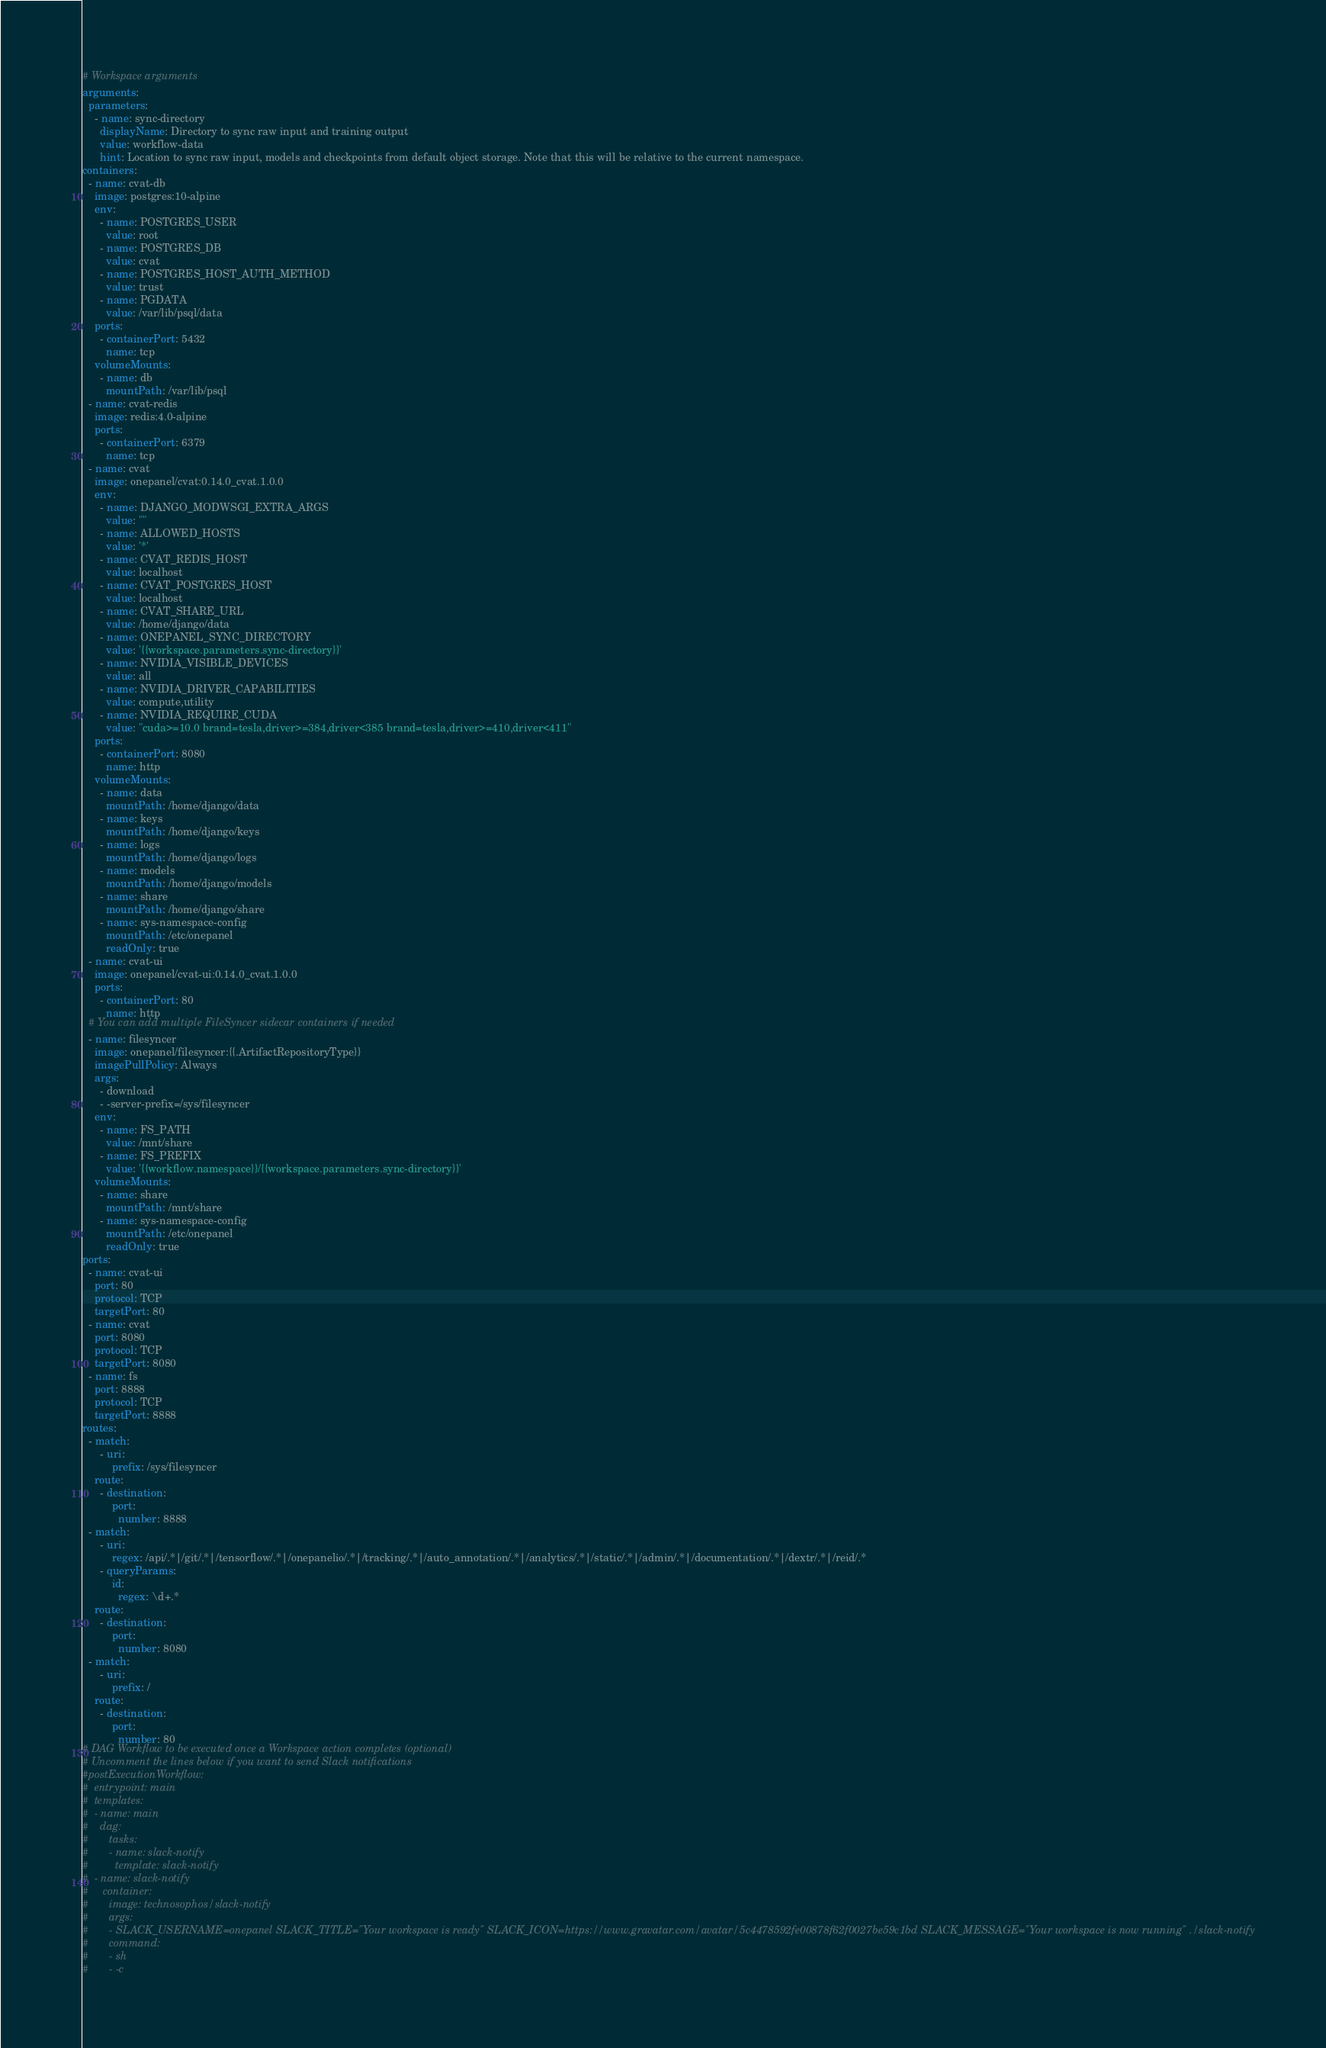<code> <loc_0><loc_0><loc_500><loc_500><_YAML_># Workspace arguments
arguments:
  parameters:
    - name: sync-directory
      displayName: Directory to sync raw input and training output
      value: workflow-data
      hint: Location to sync raw input, models and checkpoints from default object storage. Note that this will be relative to the current namespace.
containers:
  - name: cvat-db
    image: postgres:10-alpine
    env:
      - name: POSTGRES_USER
        value: root
      - name: POSTGRES_DB
        value: cvat
      - name: POSTGRES_HOST_AUTH_METHOD
        value: trust
      - name: PGDATA
        value: /var/lib/psql/data
    ports:
      - containerPort: 5432
        name: tcp
    volumeMounts:
      - name: db
        mountPath: /var/lib/psql
  - name: cvat-redis
    image: redis:4.0-alpine
    ports:
      - containerPort: 6379
        name: tcp
  - name: cvat
    image: onepanel/cvat:0.14.0_cvat.1.0.0
    env:
      - name: DJANGO_MODWSGI_EXTRA_ARGS
        value: ""
      - name: ALLOWED_HOSTS
        value: '*'
      - name: CVAT_REDIS_HOST
        value: localhost
      - name: CVAT_POSTGRES_HOST
        value: localhost
      - name: CVAT_SHARE_URL
        value: /home/django/data
      - name: ONEPANEL_SYNC_DIRECTORY
        value: '{{workspace.parameters.sync-directory}}'
      - name: NVIDIA_VISIBLE_DEVICES
        value: all
      - name: NVIDIA_DRIVER_CAPABILITIES
        value: compute,utility
      - name: NVIDIA_REQUIRE_CUDA
        value: "cuda>=10.0 brand=tesla,driver>=384,driver<385 brand=tesla,driver>=410,driver<411"
    ports:
      - containerPort: 8080
        name: http
    volumeMounts:
      - name: data
        mountPath: /home/django/data
      - name: keys
        mountPath: /home/django/keys
      - name: logs
        mountPath: /home/django/logs
      - name: models
        mountPath: /home/django/models
      - name: share
        mountPath: /home/django/share
      - name: sys-namespace-config
        mountPath: /etc/onepanel
        readOnly: true
  - name: cvat-ui
    image: onepanel/cvat-ui:0.14.0_cvat.1.0.0
    ports:
      - containerPort: 80
        name: http
  # You can add multiple FileSyncer sidecar containers if needed
  - name: filesyncer
    image: onepanel/filesyncer:{{.ArtifactRepositoryType}}
    imagePullPolicy: Always
    args:
      - download
      - -server-prefix=/sys/filesyncer
    env:
      - name: FS_PATH
        value: /mnt/share
      - name: FS_PREFIX
        value: '{{workflow.namespace}}/{{workspace.parameters.sync-directory}}'
    volumeMounts:
      - name: share
        mountPath: /mnt/share
      - name: sys-namespace-config
        mountPath: /etc/onepanel
        readOnly: true
ports:
  - name: cvat-ui
    port: 80
    protocol: TCP
    targetPort: 80
  - name: cvat
    port: 8080
    protocol: TCP
    targetPort: 8080
  - name: fs
    port: 8888
    protocol: TCP
    targetPort: 8888
routes:
  - match:
      - uri:
          prefix: /sys/filesyncer
    route:
      - destination:
          port:
            number: 8888
  - match:
      - uri:
          regex: /api/.*|/git/.*|/tensorflow/.*|/onepanelio/.*|/tracking/.*|/auto_annotation/.*|/analytics/.*|/static/.*|/admin/.*|/documentation/.*|/dextr/.*|/reid/.*
      - queryParams:
          id:
            regex: \d+.*
    route:
      - destination:
          port:
            number: 8080
  - match:
      - uri:
          prefix: /
    route:
      - destination:
          port:
            number: 80
# DAG Workflow to be executed once a Workspace action completes (optional)
# Uncomment the lines below if you want to send Slack notifications
#postExecutionWorkflow:
#  entrypoint: main
#  templates:
#  - name: main
#    dag:
#       tasks:
#       - name: slack-notify
#         template: slack-notify
#  - name: slack-notify
#     container:
#       image: technosophos/slack-notify
#       args:
#       - SLACK_USERNAME=onepanel SLACK_TITLE="Your workspace is ready" SLACK_ICON=https://www.gravatar.com/avatar/5c4478592fe00878f62f0027be59c1bd SLACK_MESSAGE="Your workspace is now running" ./slack-notify
#       command:
#       - sh
#       - -c</code> 